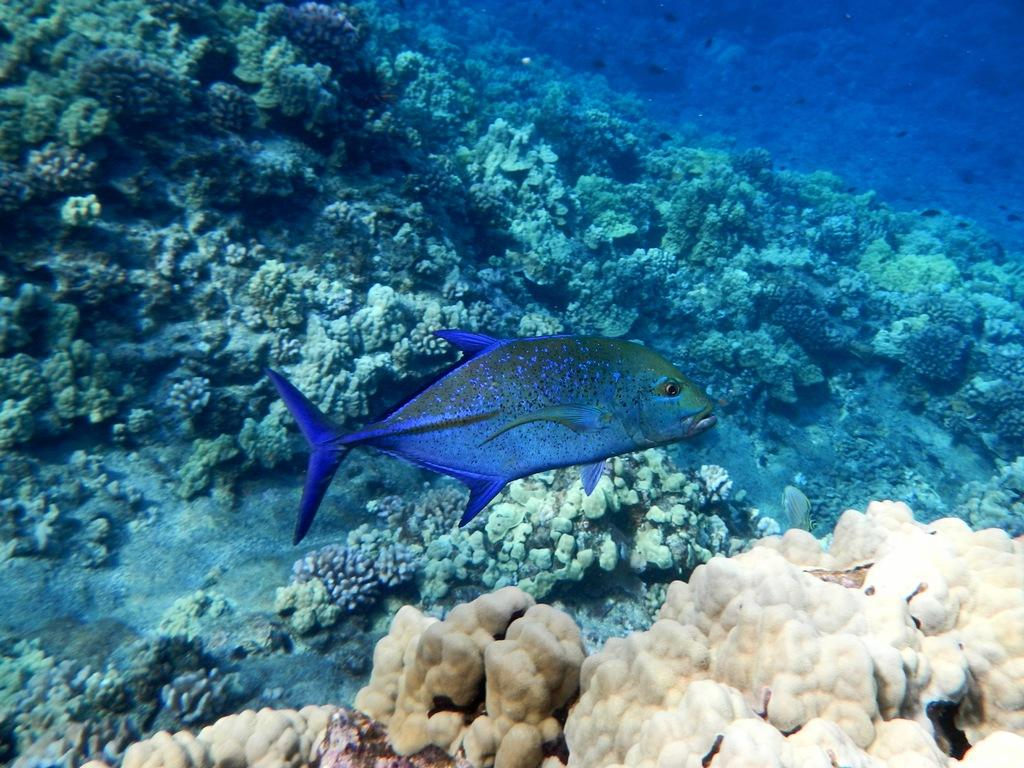What type of animal can be seen in the water in the image? There is a fish in the water in the image. What other objects or features can be seen in the image? There are corals in the image. Can you see the fish blowing a horn in the image? There is no horn present in the image, nor is the fish blowing anything. 